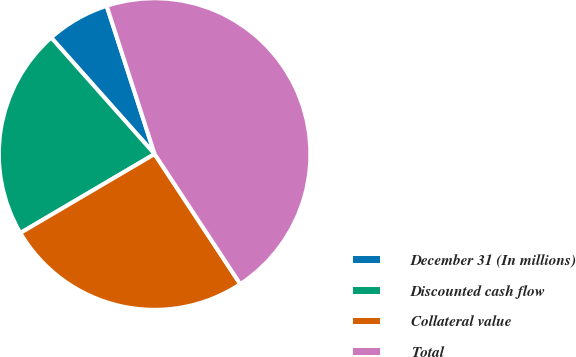Convert chart to OTSL. <chart><loc_0><loc_0><loc_500><loc_500><pie_chart><fcel>December 31 (In millions)<fcel>Discounted cash flow<fcel>Collateral value<fcel>Total<nl><fcel>6.58%<fcel>21.9%<fcel>25.81%<fcel>45.71%<nl></chart> 